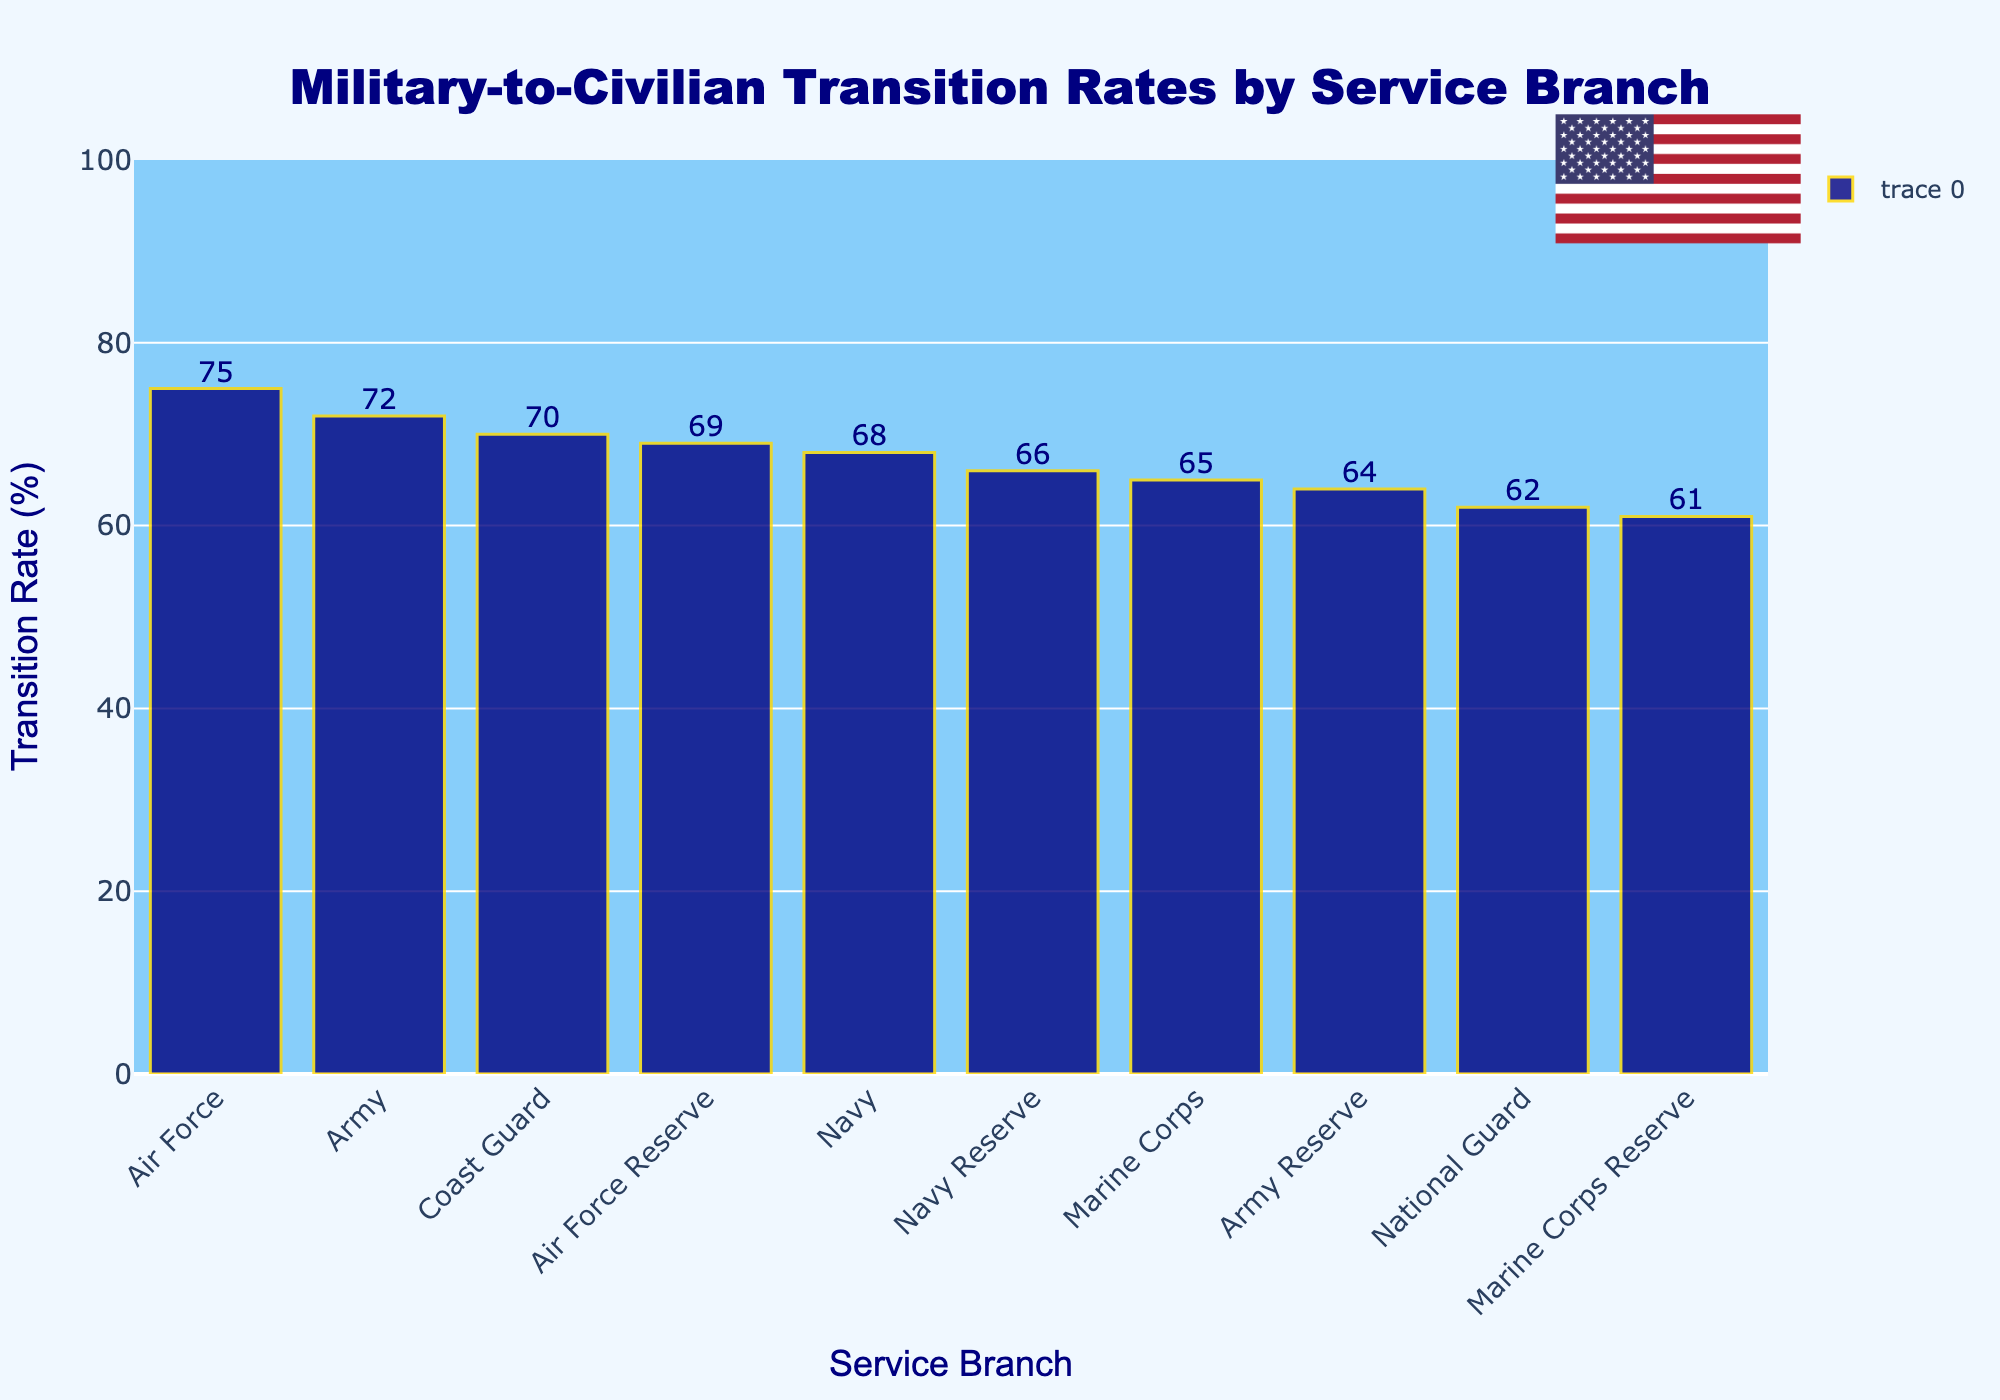What's the branch with the highest military-to-civilian transition rate? By looking at the highest bar in the chart and noting the label on the x-axis, we can see which branch has the highest transition rate. In this case, the tallest bar corresponds to the Air Force.
Answer: Air Force What is the difference in transition rates between the highest and lowest branches? The highest transition rate is for the Air Force (75%) and the lowest is for the Marine Corps Reserve (61%). Subtracting these, we get 75% - 61% = 14%.
Answer: 14% Which branches have a transition rate greater than 70%? By observing the bars that exceed the 70% mark on the y-axis, we can identify the branches. These branches are Air Force (75%), Army (72%), and Coast Guard (70%).
Answer: Air Force, Army, Coast Guard Which branch has the smallest transition rate among the reserves? By looking only at the reserve branches (Army Reserve, Air Force Reserve, Navy Reserve, Marine Corps Reserve) and comparing their respective bars, we see that the Marine Corps Reserve has the smallest transition rate (61%).
Answer: Marine Corps Reserve What's the average transition rate for all branches shown? Sum all the transition rates and divide by the number of branches: (68 + 72 + 75 + 65 + 70 + 62 + 64 + 69 + 66 + 61) / 10. This equals 672 / 10 = 67.2%.
Answer: 67.2% How many branches have a transition rate below the average rate? The average rate is 67.2%. The branches with rates below this are Marine Corps (65%), National Guard (62%), Army Reserve (64%), Navy Reserve (66%), and Marine Corps Reserve (61%). There are 5 such branches.
Answer: 5 What is the total transition rate of all reserve branches combined? Sum the transition rates of all reserve branches: Army Reserve (64%), Air Force Reserve (69%), Navy Reserve (66%), Marine Corps Reserve (61%). This equals 64 + 69 + 66 + 61 = 260%.
Answer: 260% Which branch's bar is colored navy with a gold outline? All bars in the chart are colored navy with gold outlines, so this description applies to every branch shown.
Answer: All branches 